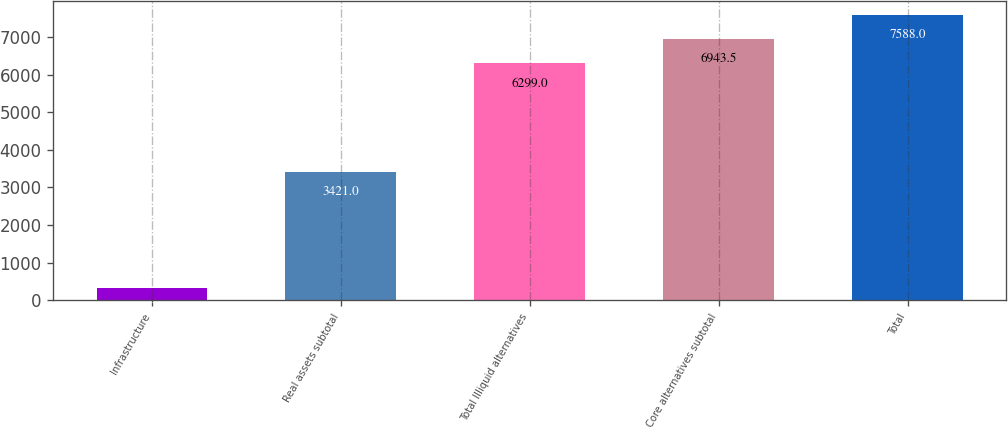Convert chart. <chart><loc_0><loc_0><loc_500><loc_500><bar_chart><fcel>Infrastructure<fcel>Real assets subtotal<fcel>Total Illiquid alternatives<fcel>Core alternatives subtotal<fcel>Total<nl><fcel>329<fcel>3421<fcel>6299<fcel>6943.5<fcel>7588<nl></chart> 